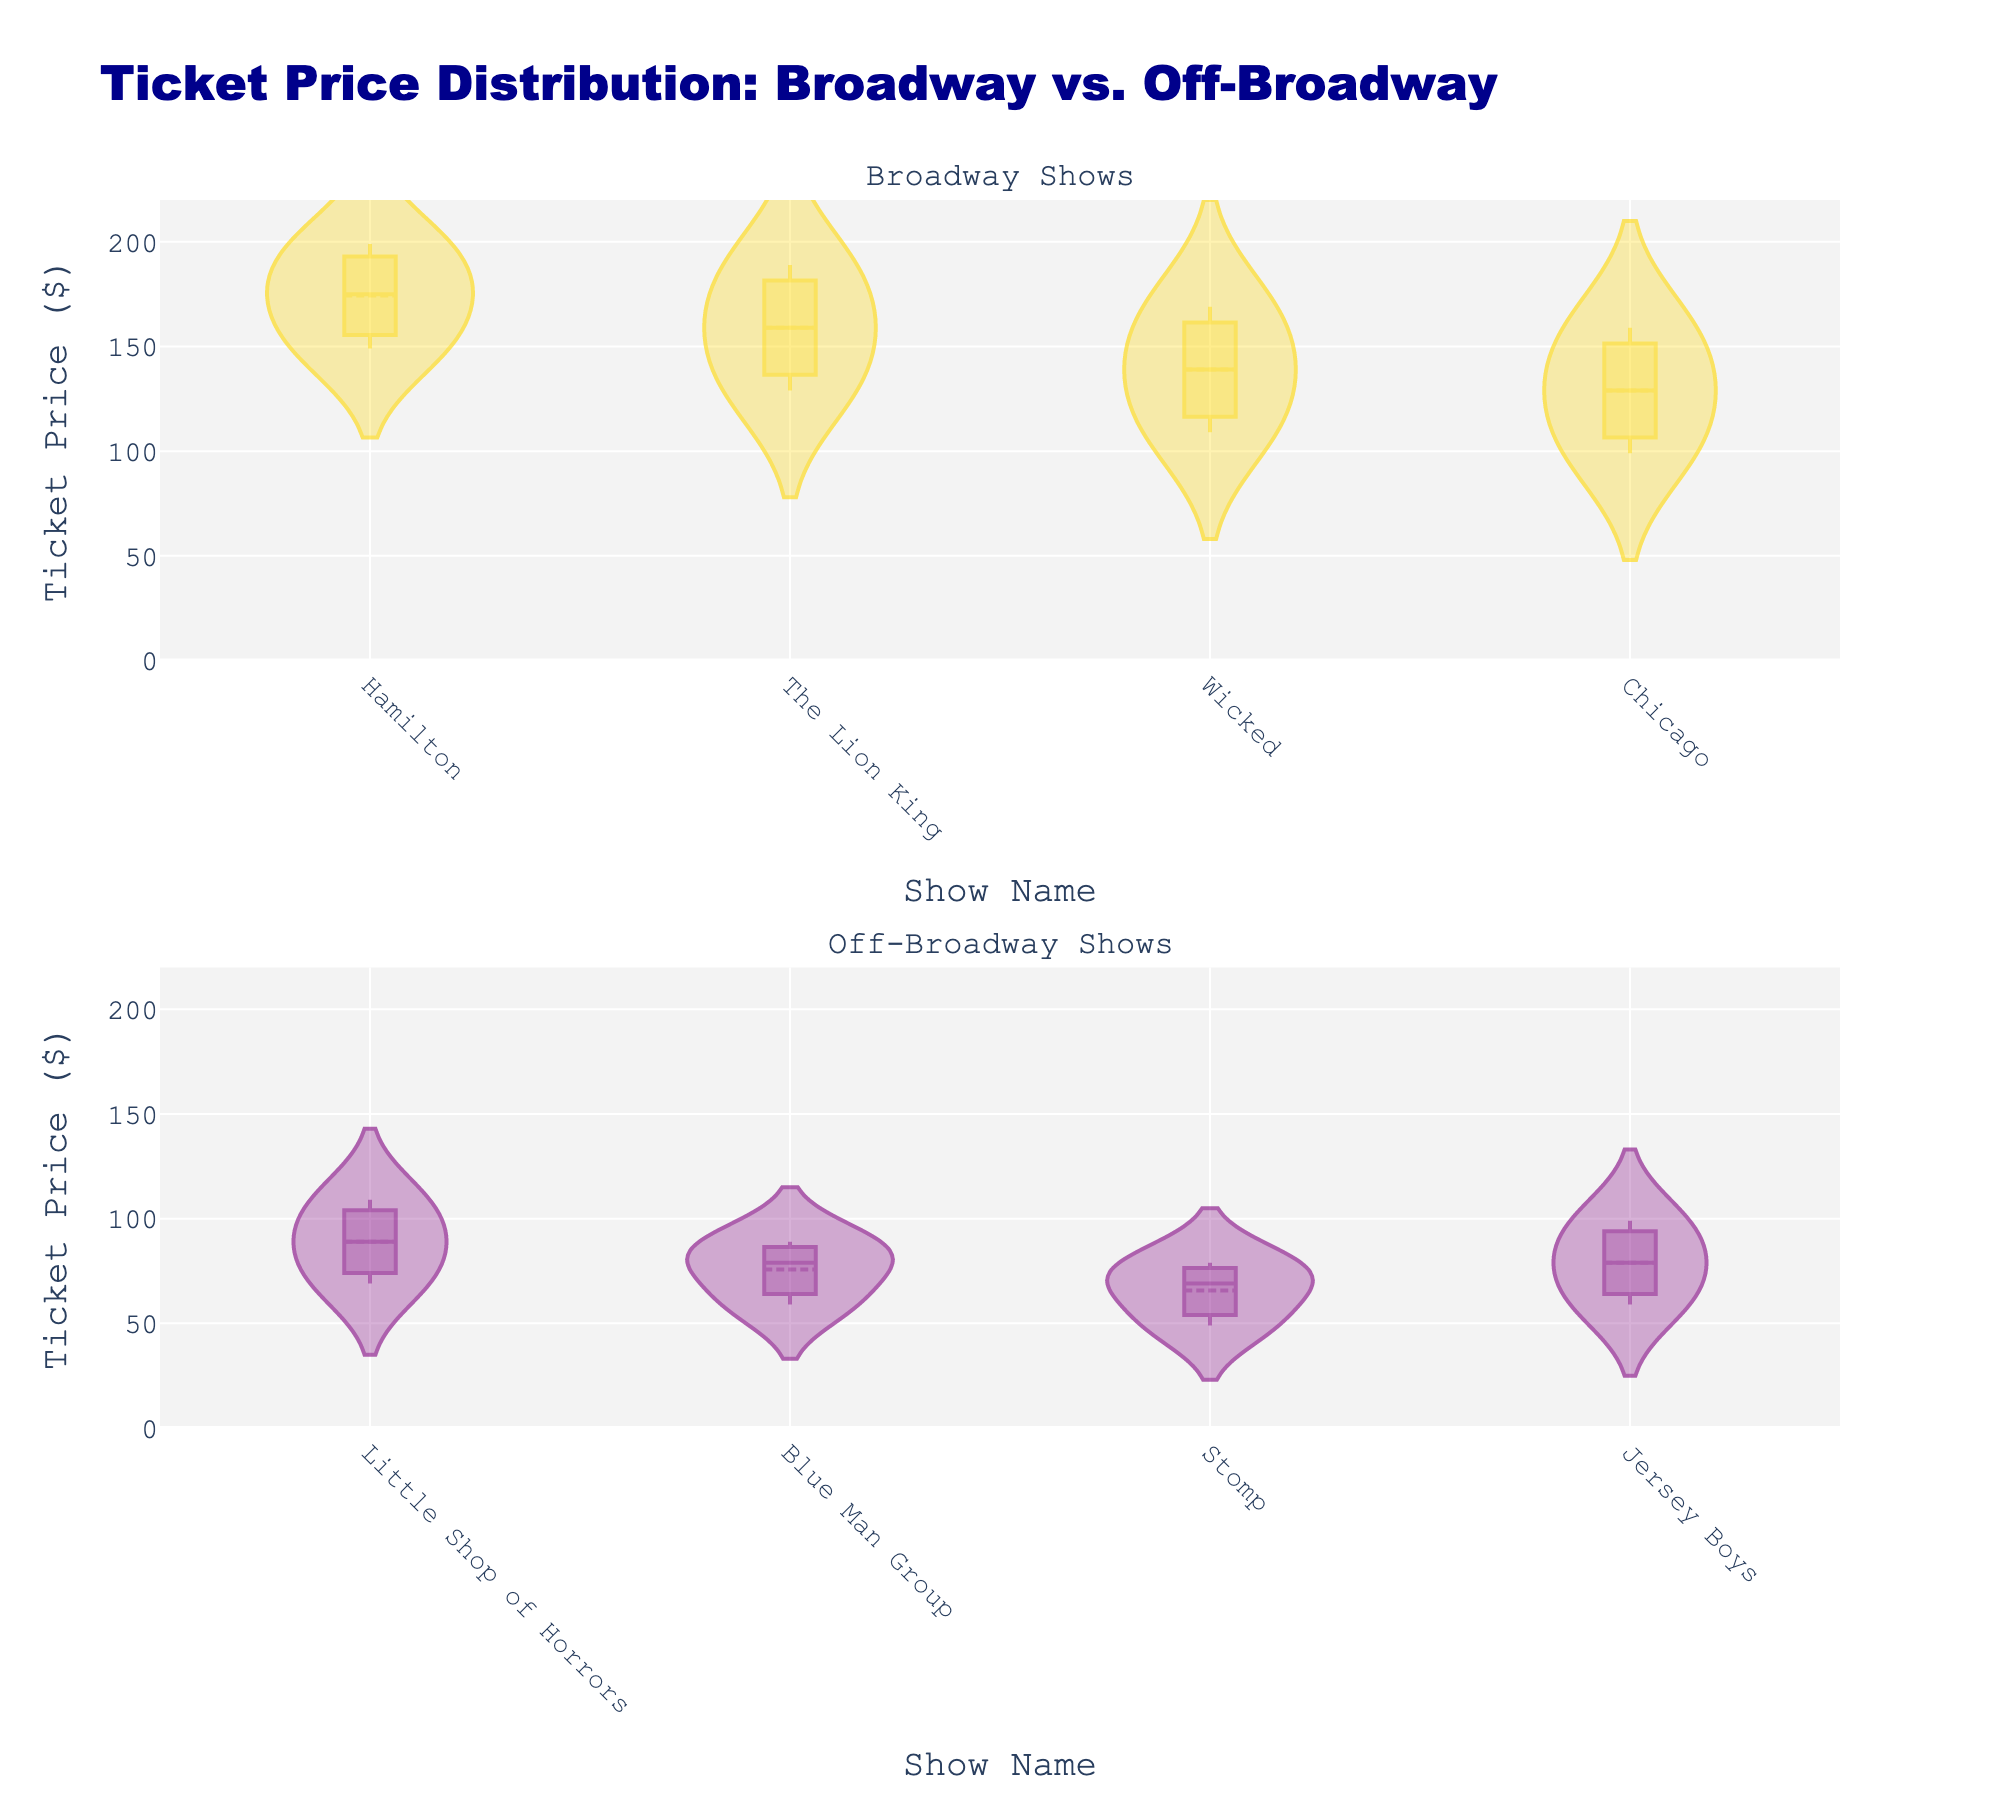What is the title of the plot? The title of the plot is displayed at the top and reads "Ticket Price Distribution: Broadway vs. Off-Broadway"
Answer: Ticket Price Distribution: Broadway vs. Off-Broadway What are the two different show types compared in the plot? The plot compares Broadway and Off-Broadway shows, as indicated by the subplot titles and the legend in the figures.
Answer: Broadway and Off-Broadway Can you name the Broadway show with the highest ticket price? The show with the highest ticket price on the Broadway subplot is "Hamilton," which has ticket prices going up to 199 dollars.
Answer: Hamilton Which Off-Broadway show has the widest range of ticket prices? By observing the densities and range of the violin plots, "Little Shop of Horrors" has the widest range of ticket prices among Off-Broadway shows, with prices spanning from 69 to 109 dollars.
Answer: Little Shop of Horrors What is the mean ticket price for "The Lion King" on Broadway? According to the mean line on the violin plot for "The Lion King," the mean ticket price is shown by the central white dot, which appears around 159 dollars.
Answer: 159 Do any Off-Broadway shows have a ticket price higher than the lowest ticket price on Broadway? The lowest ticket price on Broadway is 99 dollars (Chicago), and all Off-Broadway ticket prices are below this. Hence, no Off-Broadway show has a ticket price higher than 99 dollars.
Answer: No How does the ticket price distribution for "Wicked" compare to that of "Stomp"? "Wicked" on Broadway shows a distribution from approximately 109 to 169 dollars, whereas "Stomp" off-Broadway shows a distribution from approximately 49 to 79 dollars. "Wicked" has higher ticket prices overall.
Answer: "Wicked" has higher ticket prices What is the difference between the highest ticket price on Broadway and the lowest ticket price off-Broadway? The highest ticket price on Broadway is 199 dollars ("Hamilton") and the lowest off-Broadway is 49 dollars ("Stomp"). The difference is 199 - 49 = 150 dollars.
Answer: 150 dollars Which show type exhibits a more consistent ticket pricing, Broadway or Off-Broadway? Consistency in ticket pricing can be inferred by the spread and shape of the violin plots. Broadway shows appear to have a tighter and more consistent price range compared to the more varied spreads of Off-Broadway shows.
Answer: Broadway Are there any shows with overlapping ticket price ranges between Broadway and Off-Broadway? By examining the density plots, there is no overlap in the ticket price ranges. Broadway tickets start at 99 dollars (Chicago) and above, while Off-Broadway tickets do not exceed 109 dollars (Little Shop of Horrors).
Answer: No 